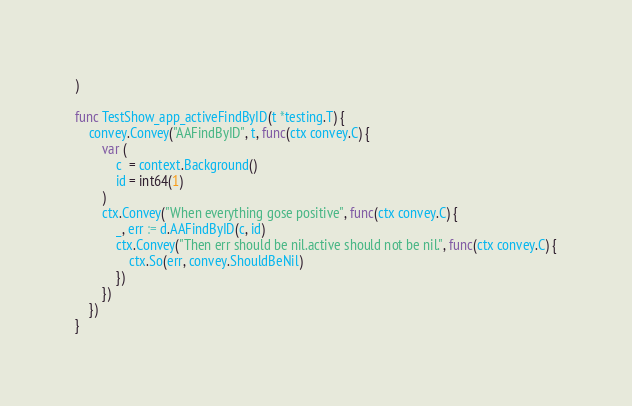<code> <loc_0><loc_0><loc_500><loc_500><_Go_>)

func TestShow_app_activeFindByID(t *testing.T) {
	convey.Convey("AAFindByID", t, func(ctx convey.C) {
		var (
			c  = context.Background()
			id = int64(1)
		)
		ctx.Convey("When everything gose positive", func(ctx convey.C) {
			_, err := d.AAFindByID(c, id)
			ctx.Convey("Then err should be nil.active should not be nil.", func(ctx convey.C) {
				ctx.So(err, convey.ShouldBeNil)
			})
		})
	})
}
</code> 